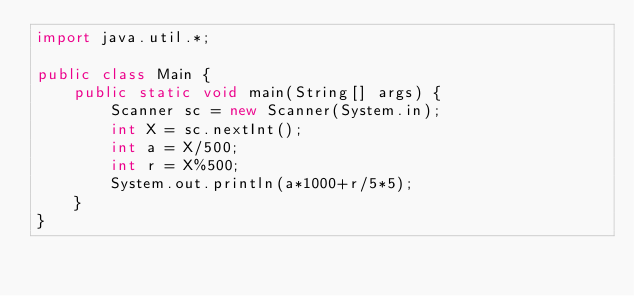Convert code to text. <code><loc_0><loc_0><loc_500><loc_500><_Java_>import java.util.*;

public class Main {
    public static void main(String[] args) {
        Scanner sc = new Scanner(System.in);
        int X = sc.nextInt();
        int a = X/500;
        int r = X%500;
        System.out.println(a*1000+r/5*5);
    }
}

</code> 